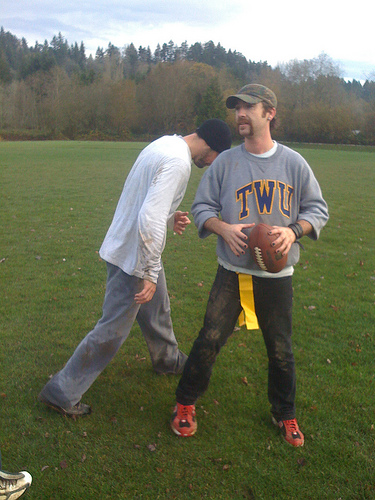<image>
Can you confirm if the left man is in front of the right man? No. The left man is not in front of the right man. The spatial positioning shows a different relationship between these objects. 